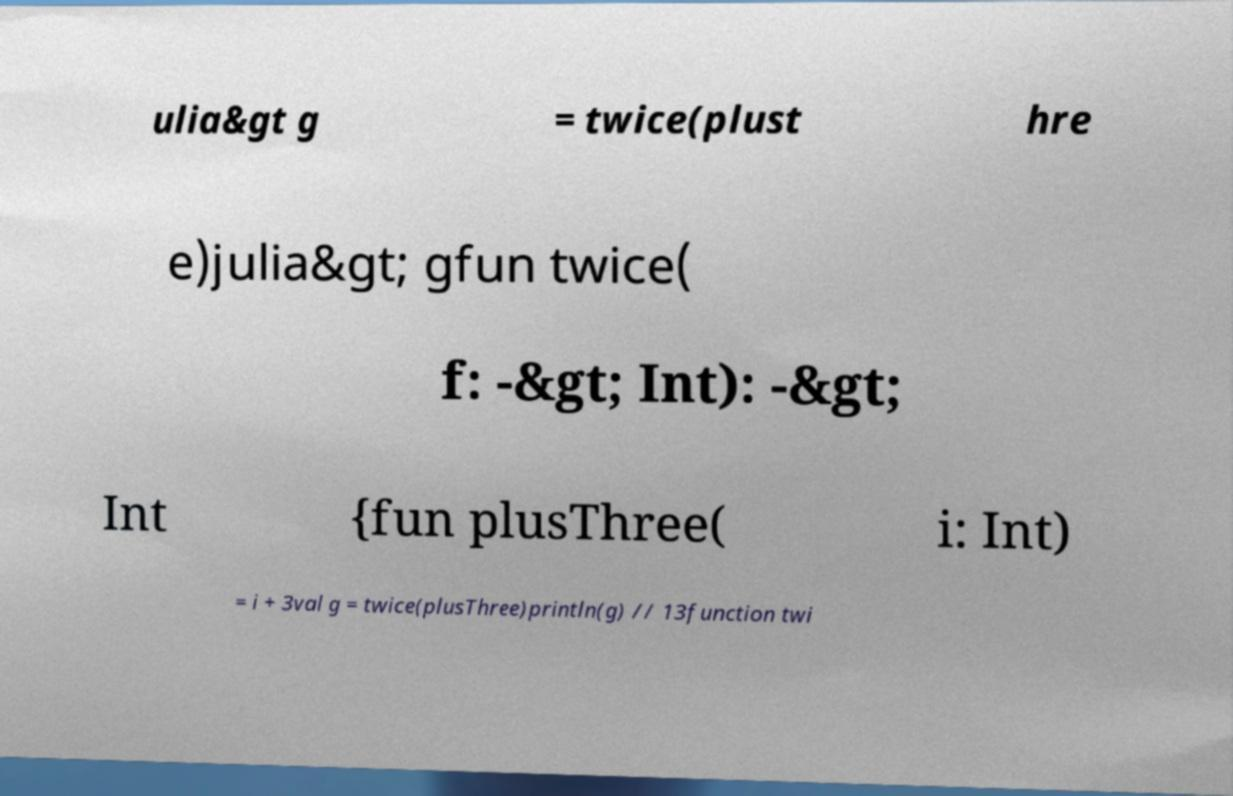Can you read and provide the text displayed in the image?This photo seems to have some interesting text. Can you extract and type it out for me? ulia&gt g = twice(plust hre e)julia&gt; gfun twice( f: -&gt; Int): -&gt; Int {fun plusThree( i: Int) = i + 3val g = twice(plusThree)println(g) // 13function twi 